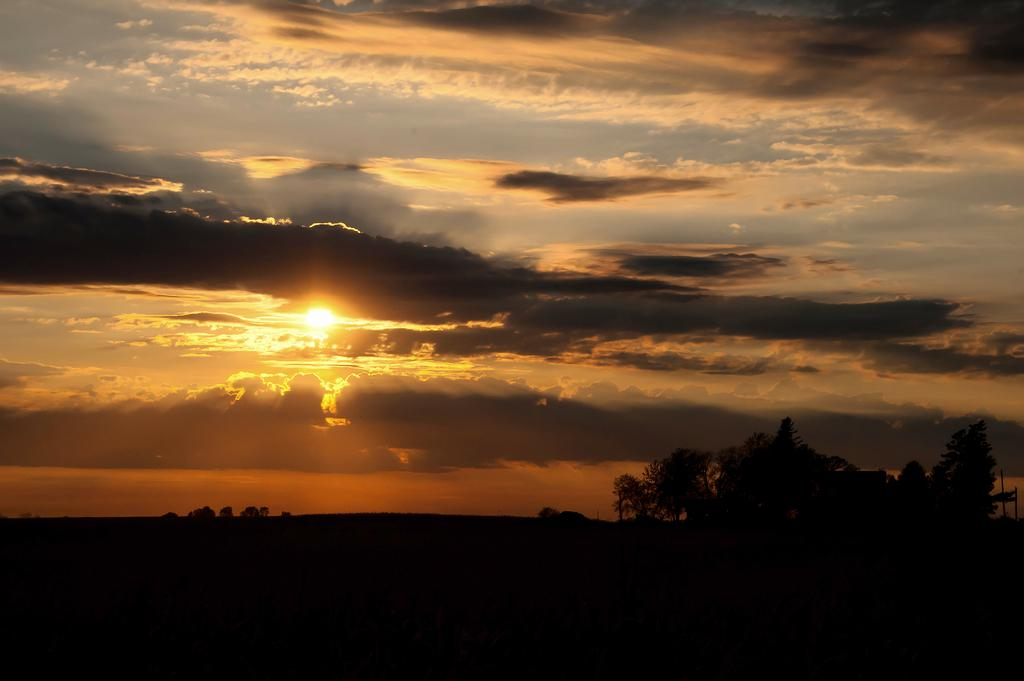What type of vegetation can be seen in the front of the image? There are trees in the front of the image. What can be seen in the background of the image? There are clouds, the sun, and the sky visible in the background of the image. Can you see any jellyfish floating in the sky in the image? There are no jellyfish present in the image; it features trees, clouds, the sun, and the sky. What type of beam is holding up the clouds in the image? There is no beam present in the image; the clouds are naturally suspended in the sky. 